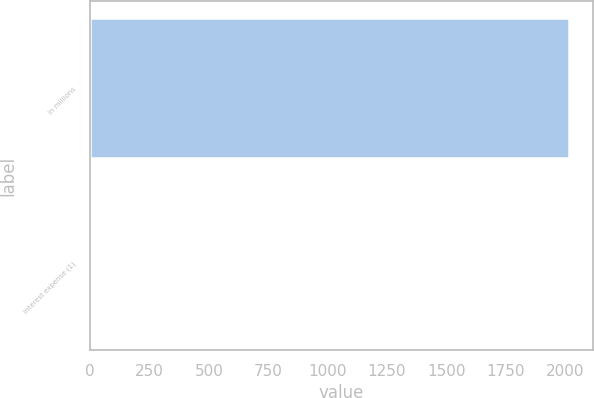Convert chart. <chart><loc_0><loc_0><loc_500><loc_500><bar_chart><fcel>In millions<fcel>Interest expense (1)<nl><fcel>2016<fcel>8<nl></chart> 